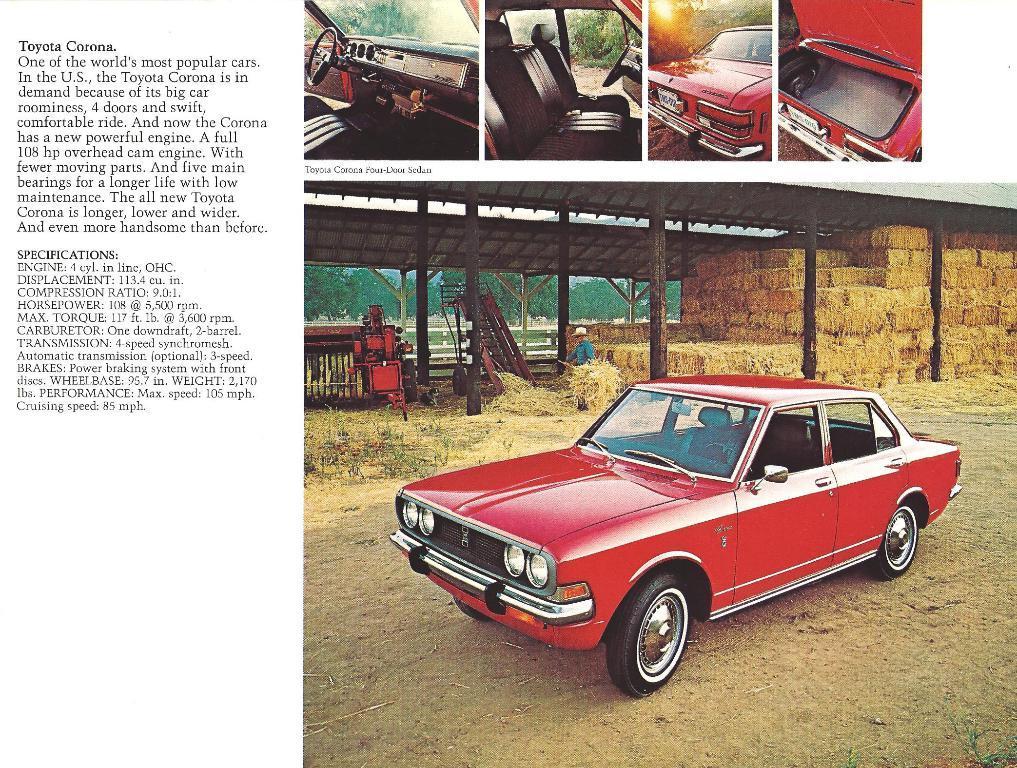Could you give a brief overview of what you see in this image? This is a collage picture and in this picture we can see a car on the ground, steering wheel, seats, trees and a person standing and on left side of the image we can see some text. 